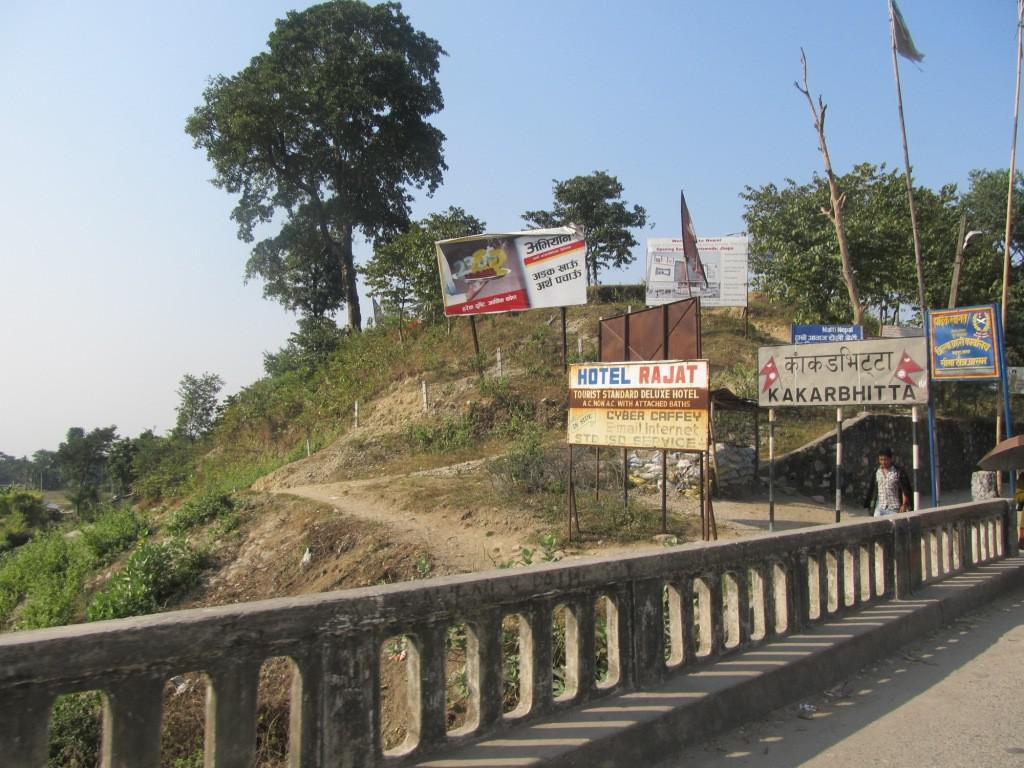<image>
Share a concise interpretation of the image provided. Behind a billboard for Hotel Rajat, on a dirt pathway, are several other billboards with foreign languages written on them. 